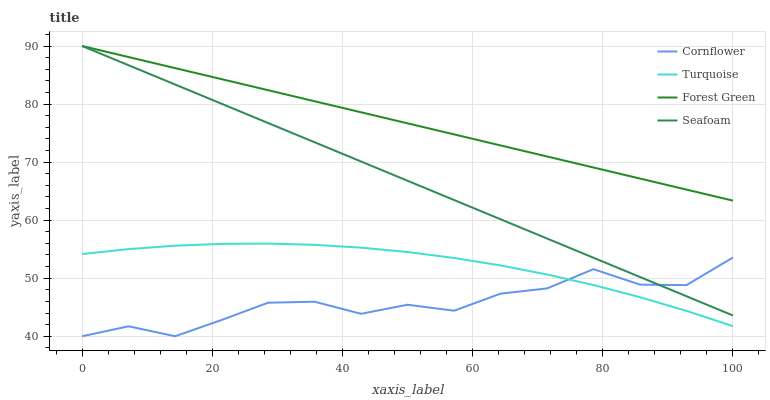Does Cornflower have the minimum area under the curve?
Answer yes or no. Yes. Does Forest Green have the maximum area under the curve?
Answer yes or no. Yes. Does Turquoise have the minimum area under the curve?
Answer yes or no. No. Does Turquoise have the maximum area under the curve?
Answer yes or no. No. Is Seafoam the smoothest?
Answer yes or no. Yes. Is Cornflower the roughest?
Answer yes or no. Yes. Is Turquoise the smoothest?
Answer yes or no. No. Is Turquoise the roughest?
Answer yes or no. No. Does Cornflower have the lowest value?
Answer yes or no. Yes. Does Turquoise have the lowest value?
Answer yes or no. No. Does Seafoam have the highest value?
Answer yes or no. Yes. Does Turquoise have the highest value?
Answer yes or no. No. Is Cornflower less than Forest Green?
Answer yes or no. Yes. Is Forest Green greater than Cornflower?
Answer yes or no. Yes. Does Cornflower intersect Turquoise?
Answer yes or no. Yes. Is Cornflower less than Turquoise?
Answer yes or no. No. Is Cornflower greater than Turquoise?
Answer yes or no. No. Does Cornflower intersect Forest Green?
Answer yes or no. No. 